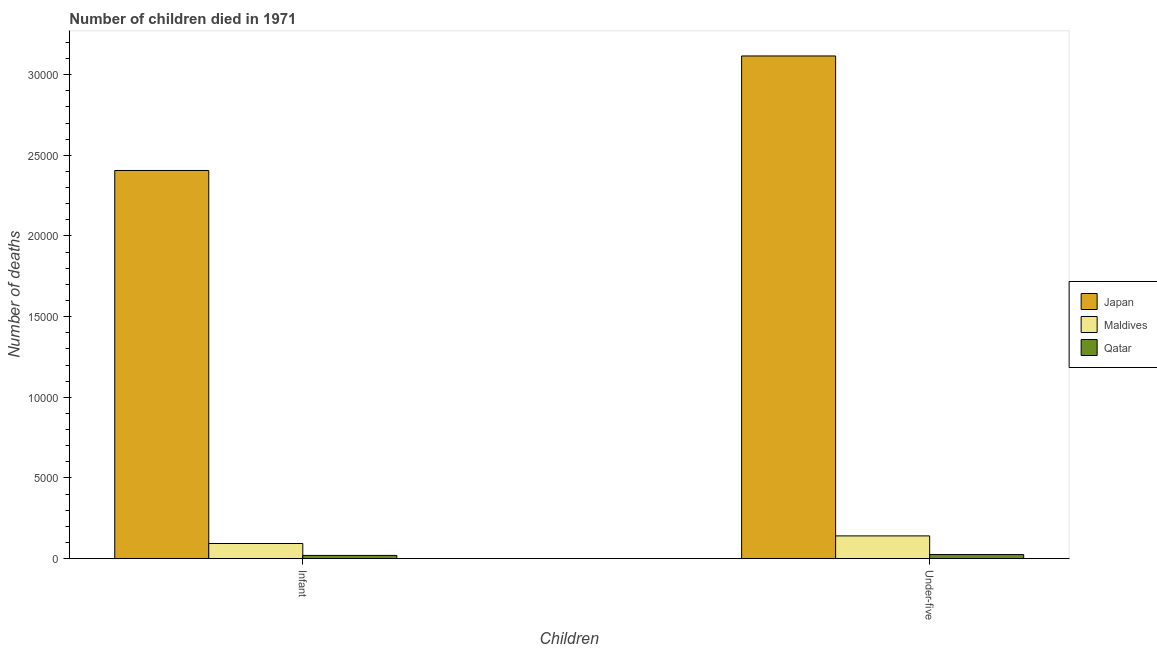How many groups of bars are there?
Provide a succinct answer. 2. Are the number of bars per tick equal to the number of legend labels?
Offer a very short reply. Yes. What is the label of the 1st group of bars from the left?
Give a very brief answer. Infant. What is the number of infant deaths in Maldives?
Your answer should be very brief. 934. Across all countries, what is the maximum number of infant deaths?
Provide a short and direct response. 2.41e+04. Across all countries, what is the minimum number of infant deaths?
Provide a succinct answer. 196. In which country was the number of infant deaths minimum?
Your answer should be compact. Qatar. What is the total number of under-five deaths in the graph?
Make the answer very short. 3.28e+04. What is the difference between the number of infant deaths in Maldives and that in Qatar?
Offer a terse response. 738. What is the difference between the number of infant deaths in Maldives and the number of under-five deaths in Japan?
Ensure brevity in your answer.  -3.02e+04. What is the average number of under-five deaths per country?
Provide a succinct answer. 1.09e+04. What is the difference between the number of under-five deaths and number of infant deaths in Qatar?
Provide a succinct answer. 53. What is the ratio of the number of under-five deaths in Japan to that in Qatar?
Offer a terse response. 125.14. Is the number of infant deaths in Maldives less than that in Japan?
Offer a terse response. Yes. What does the 1st bar from the right in Infant represents?
Make the answer very short. Qatar. How many bars are there?
Your answer should be very brief. 6. Are all the bars in the graph horizontal?
Ensure brevity in your answer.  No. How many countries are there in the graph?
Make the answer very short. 3. Does the graph contain any zero values?
Your response must be concise. No. Does the graph contain grids?
Your answer should be very brief. No. How are the legend labels stacked?
Ensure brevity in your answer.  Vertical. What is the title of the graph?
Make the answer very short. Number of children died in 1971. Does "Marshall Islands" appear as one of the legend labels in the graph?
Offer a terse response. No. What is the label or title of the X-axis?
Keep it short and to the point. Children. What is the label or title of the Y-axis?
Give a very brief answer. Number of deaths. What is the Number of deaths of Japan in Infant?
Your answer should be compact. 2.41e+04. What is the Number of deaths of Maldives in Infant?
Make the answer very short. 934. What is the Number of deaths of Qatar in Infant?
Provide a succinct answer. 196. What is the Number of deaths of Japan in Under-five?
Offer a very short reply. 3.12e+04. What is the Number of deaths of Maldives in Under-five?
Your answer should be very brief. 1405. What is the Number of deaths of Qatar in Under-five?
Your answer should be very brief. 249. Across all Children, what is the maximum Number of deaths in Japan?
Offer a very short reply. 3.12e+04. Across all Children, what is the maximum Number of deaths of Maldives?
Your response must be concise. 1405. Across all Children, what is the maximum Number of deaths of Qatar?
Provide a succinct answer. 249. Across all Children, what is the minimum Number of deaths in Japan?
Your answer should be very brief. 2.41e+04. Across all Children, what is the minimum Number of deaths of Maldives?
Offer a terse response. 934. Across all Children, what is the minimum Number of deaths of Qatar?
Make the answer very short. 196. What is the total Number of deaths of Japan in the graph?
Keep it short and to the point. 5.52e+04. What is the total Number of deaths of Maldives in the graph?
Offer a very short reply. 2339. What is the total Number of deaths of Qatar in the graph?
Offer a terse response. 445. What is the difference between the Number of deaths of Japan in Infant and that in Under-five?
Provide a short and direct response. -7100. What is the difference between the Number of deaths in Maldives in Infant and that in Under-five?
Your answer should be compact. -471. What is the difference between the Number of deaths in Qatar in Infant and that in Under-five?
Ensure brevity in your answer.  -53. What is the difference between the Number of deaths in Japan in Infant and the Number of deaths in Maldives in Under-five?
Offer a very short reply. 2.27e+04. What is the difference between the Number of deaths in Japan in Infant and the Number of deaths in Qatar in Under-five?
Provide a short and direct response. 2.38e+04. What is the difference between the Number of deaths in Maldives in Infant and the Number of deaths in Qatar in Under-five?
Make the answer very short. 685. What is the average Number of deaths in Japan per Children?
Ensure brevity in your answer.  2.76e+04. What is the average Number of deaths in Maldives per Children?
Your response must be concise. 1169.5. What is the average Number of deaths in Qatar per Children?
Provide a succinct answer. 222.5. What is the difference between the Number of deaths in Japan and Number of deaths in Maldives in Infant?
Your answer should be compact. 2.31e+04. What is the difference between the Number of deaths in Japan and Number of deaths in Qatar in Infant?
Ensure brevity in your answer.  2.39e+04. What is the difference between the Number of deaths in Maldives and Number of deaths in Qatar in Infant?
Your response must be concise. 738. What is the difference between the Number of deaths in Japan and Number of deaths in Maldives in Under-five?
Provide a succinct answer. 2.98e+04. What is the difference between the Number of deaths in Japan and Number of deaths in Qatar in Under-five?
Provide a succinct answer. 3.09e+04. What is the difference between the Number of deaths of Maldives and Number of deaths of Qatar in Under-five?
Keep it short and to the point. 1156. What is the ratio of the Number of deaths in Japan in Infant to that in Under-five?
Give a very brief answer. 0.77. What is the ratio of the Number of deaths in Maldives in Infant to that in Under-five?
Offer a very short reply. 0.66. What is the ratio of the Number of deaths of Qatar in Infant to that in Under-five?
Offer a terse response. 0.79. What is the difference between the highest and the second highest Number of deaths in Japan?
Your response must be concise. 7100. What is the difference between the highest and the second highest Number of deaths of Maldives?
Your answer should be compact. 471. What is the difference between the highest and the lowest Number of deaths in Japan?
Offer a very short reply. 7100. What is the difference between the highest and the lowest Number of deaths of Maldives?
Provide a succinct answer. 471. 